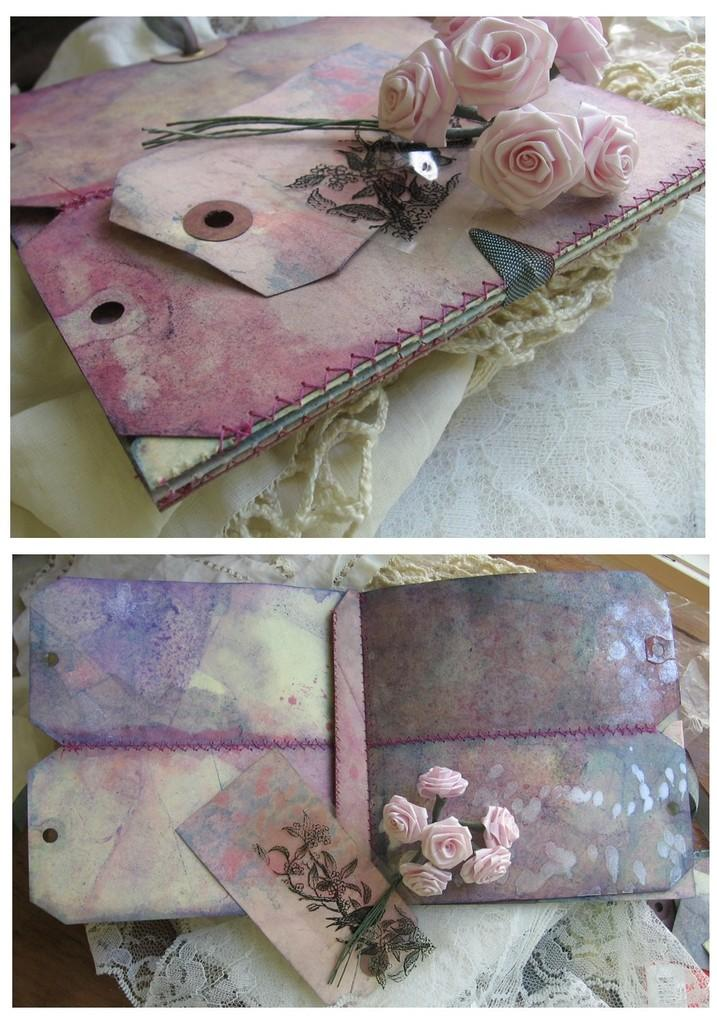What type of establishment is depicted in the image? There is a dairy in the image. What type of flowers can be seen in the image? There are roses in the image. What type of material is present in the image? There is a cloth in the image. What type of whip is being used to stir the soup in the image? There is no whip or soup present in the image. How is the cord being used in the image? There is no cord present in the image. 